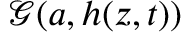<formula> <loc_0><loc_0><loc_500><loc_500>\mathcal { G } ( a , h ( z , t ) )</formula> 